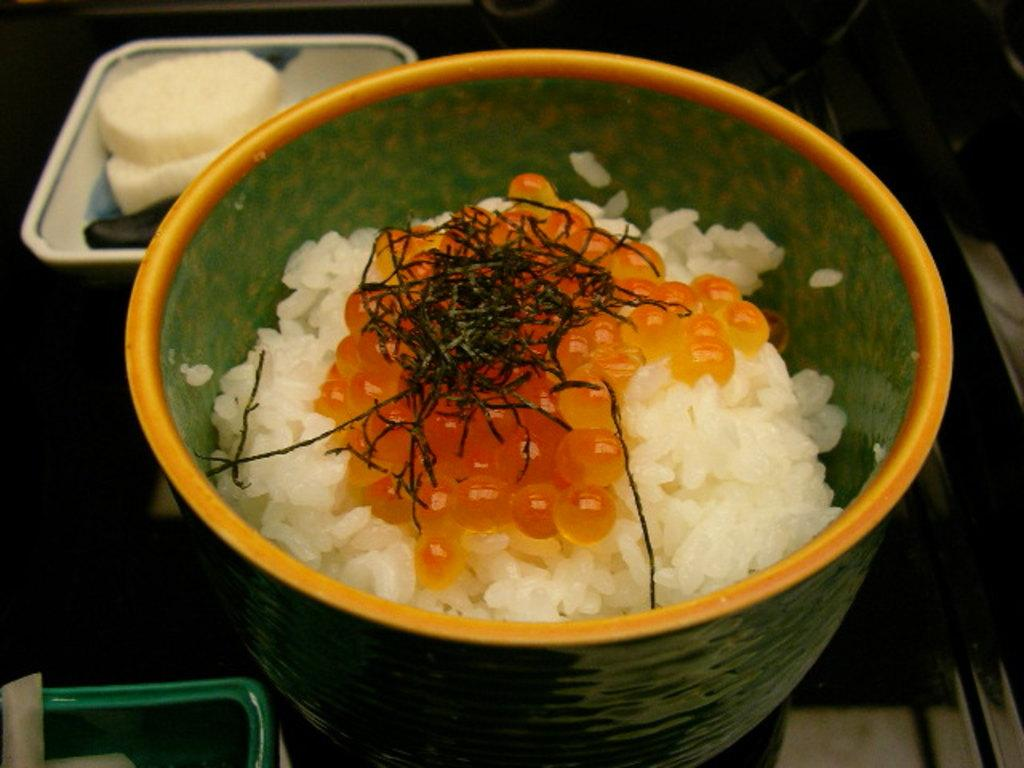How many bowls are visible in the image? There are two bowls in the image. What is inside the bowls? The bowls contain food items. Can you describe the object in the bottom left-hand corner of the image? There is a metal object in the bottom left-hand corner of the image. What is the color of the background in the image? The background of the image is dark. What type of shoes can be seen in the image? There are no shoes present in the image. Can you tell me which vein is visible in the image? There are no veins visible in the image. 